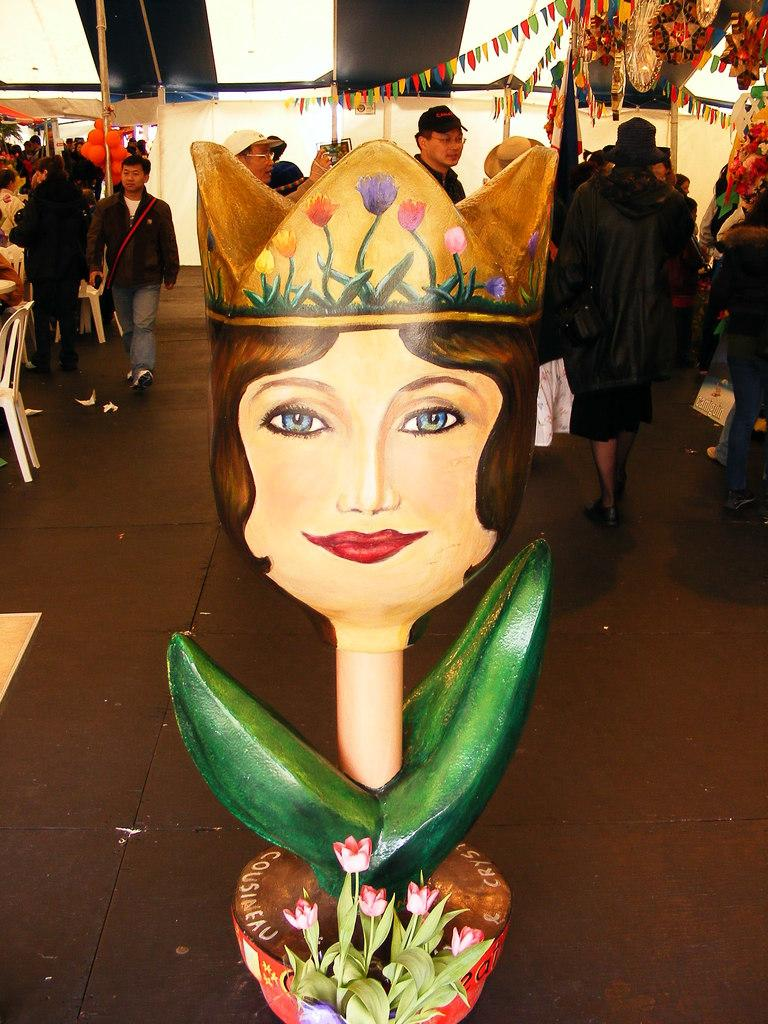What can be seen in the foreground of the image? There are flowers and a sculpture in the foreground of the image. What is visible in the background of the image? There are people in the background of the image. Where is the white chair located in the image? The white chair is on the left side of the image. What are the poles in the image used for? The poles in the image are used to hold flags at the top. What type of bridge can be seen connecting the flowers in the image? There is no bridge present in the image; it features flowers, a sculpture, people, a white chair, poles, and flags. What theory is being discussed by the people in the background of the image? There is no indication in the image that the people are discussing any theories. 